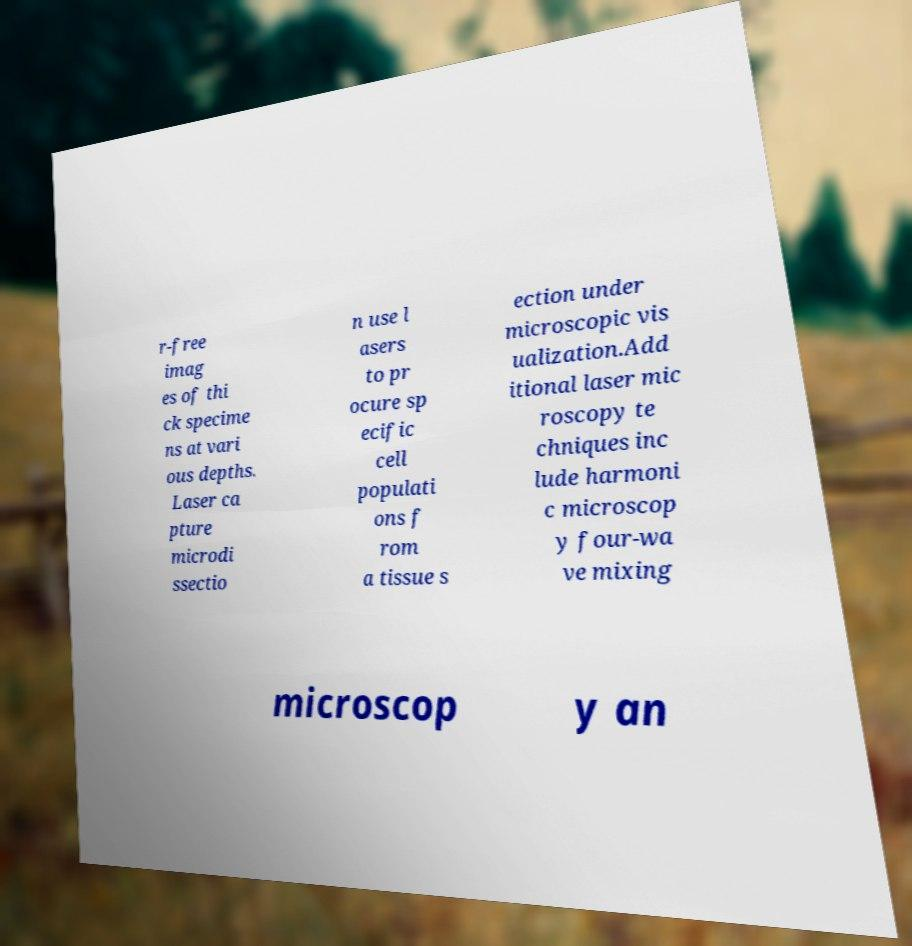What messages or text are displayed in this image? I need them in a readable, typed format. r-free imag es of thi ck specime ns at vari ous depths. Laser ca pture microdi ssectio n use l asers to pr ocure sp ecific cell populati ons f rom a tissue s ection under microscopic vis ualization.Add itional laser mic roscopy te chniques inc lude harmoni c microscop y four-wa ve mixing microscop y an 